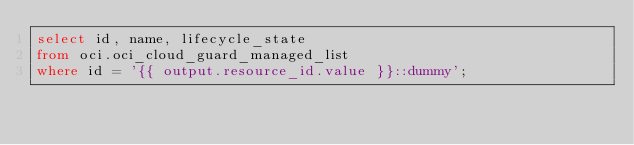<code> <loc_0><loc_0><loc_500><loc_500><_SQL_>select id, name, lifecycle_state
from oci.oci_cloud_guard_managed_list
where id = '{{ output.resource_id.value }}::dummy';</code> 